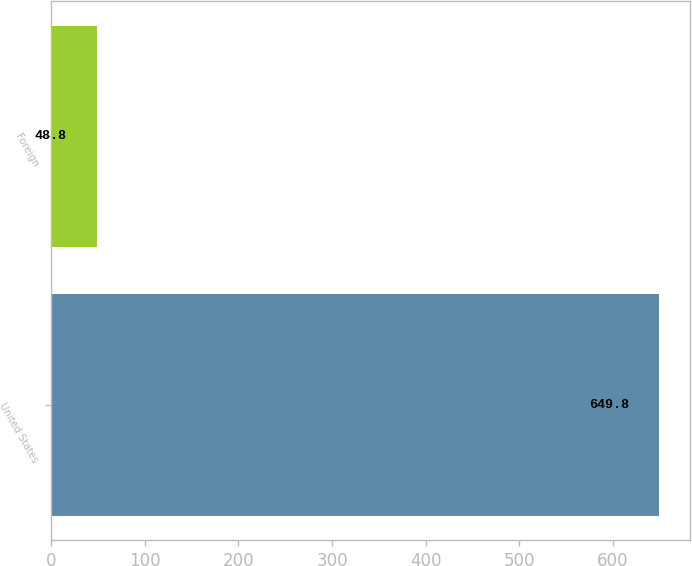Convert chart. <chart><loc_0><loc_0><loc_500><loc_500><bar_chart><fcel>United States<fcel>Foreign<nl><fcel>649.8<fcel>48.8<nl></chart> 